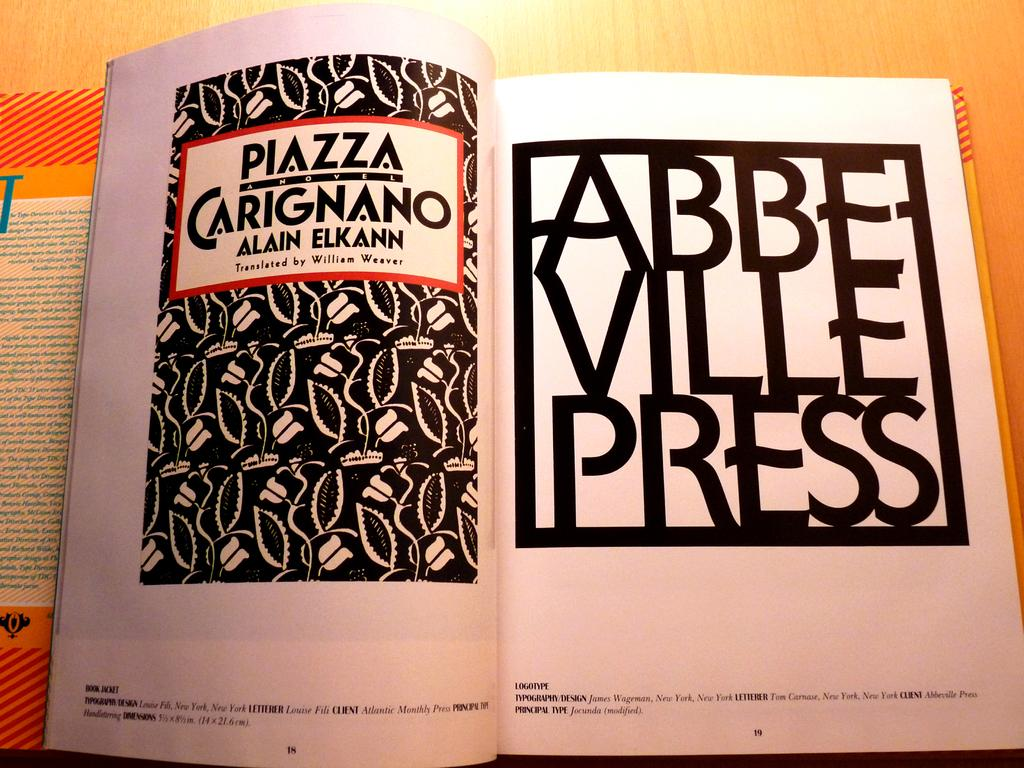<image>
Offer a succinct explanation of the picture presented. A book opened to the title page called Piazza Carignano. 